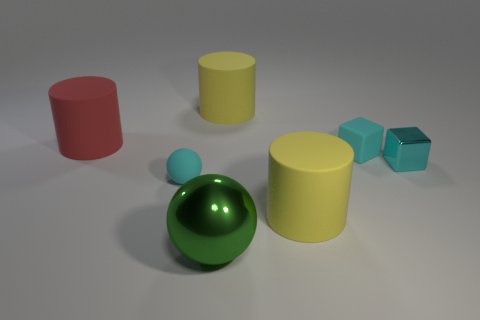Subtract all red matte cylinders. How many cylinders are left? 2 Add 1 red cylinders. How many objects exist? 8 Subtract all brown cylinders. Subtract all brown cubes. How many cylinders are left? 3 Subtract all blocks. How many objects are left? 5 Add 5 large green shiny balls. How many large green shiny balls are left? 6 Add 2 big yellow matte objects. How many big yellow matte objects exist? 4 Subtract 0 blue balls. How many objects are left? 7 Subtract all spheres. Subtract all big gray matte cylinders. How many objects are left? 5 